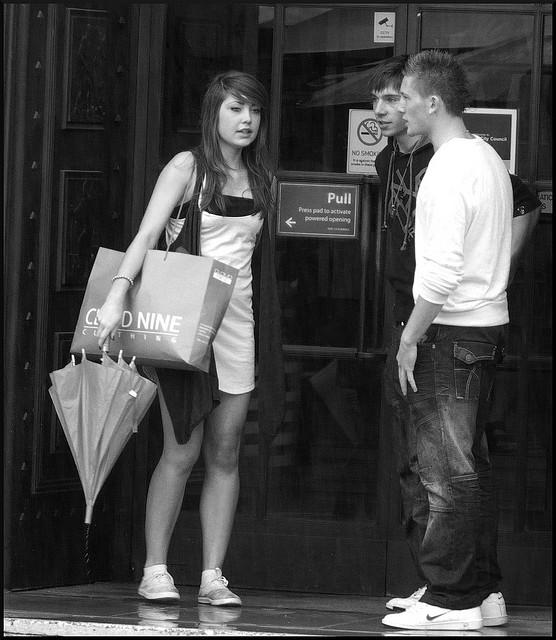What are the boys doing? talking 